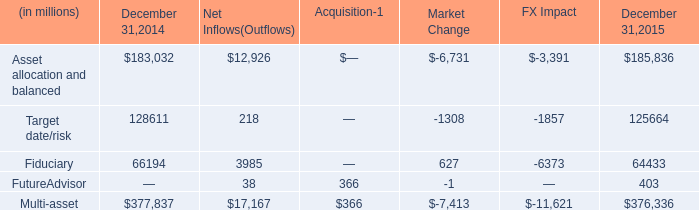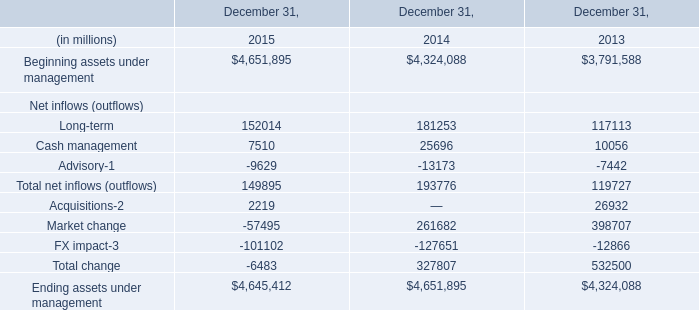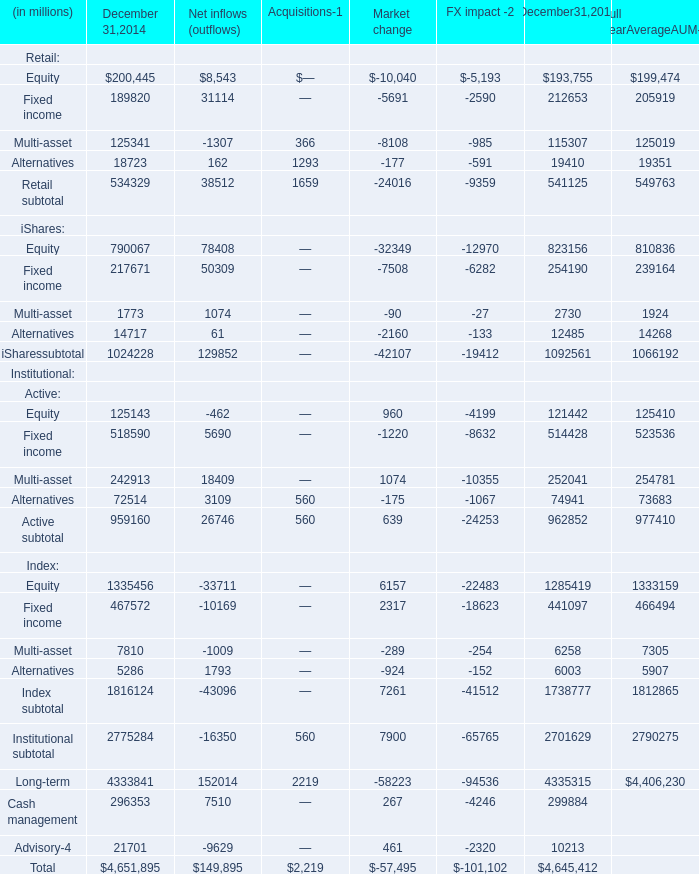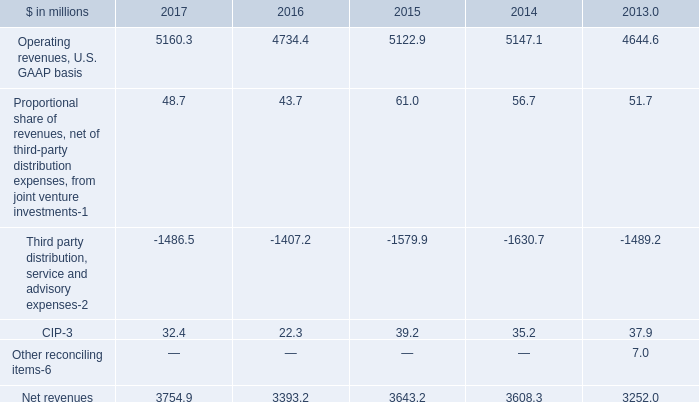what is the growth rate in the balance of total multi assets from 2014 to 2015? 
Computations: ((376336 - 377837) / 377837)
Answer: -0.00397. 